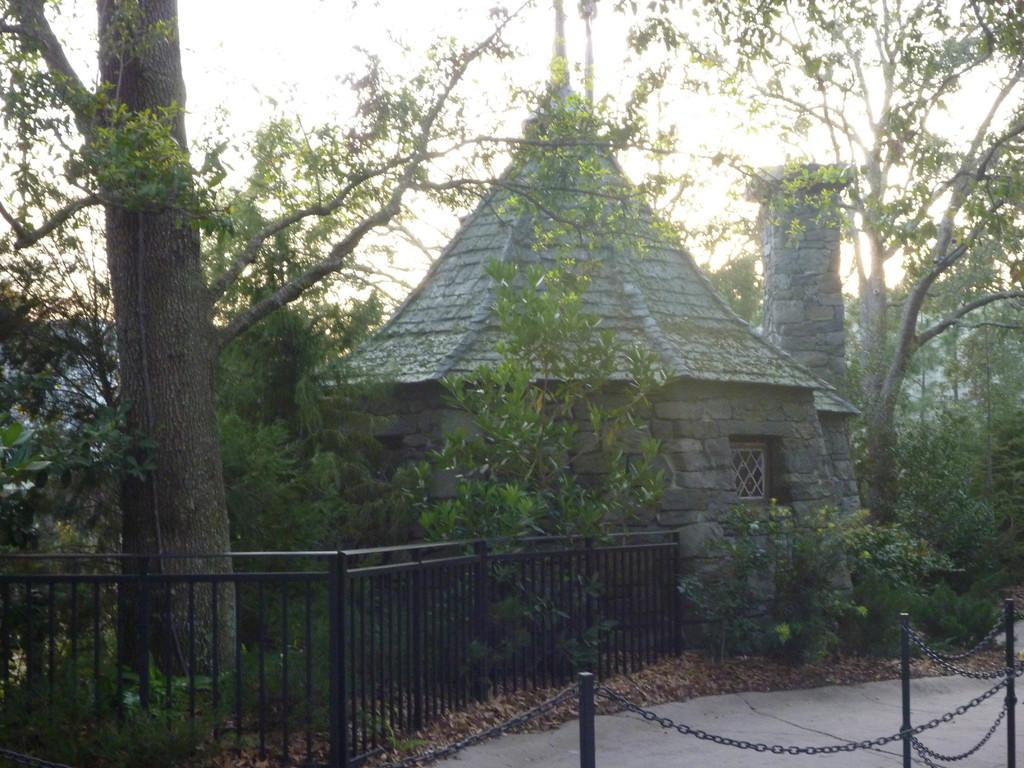What structures can be seen in the image? There are poles and a house in the image. What other objects are present in the image? There are chains, trees, and plants in the image. What can be seen in the background of the image? The sky is visible in the background of the image. What type of wound can be seen on the fireman in the image? There is no fireman present in the image, and therefore no wound can be observed. 